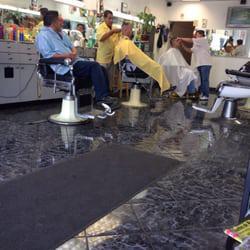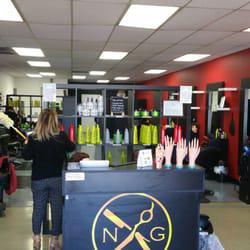The first image is the image on the left, the second image is the image on the right. For the images displayed, is the sentence "In at least one image there are three people getting their haircut." factually correct? Answer yes or no. Yes. The first image is the image on the left, the second image is the image on the right. Given the left and right images, does the statement "The combined images include two barber shop doors and two barber poles." hold true? Answer yes or no. No. 